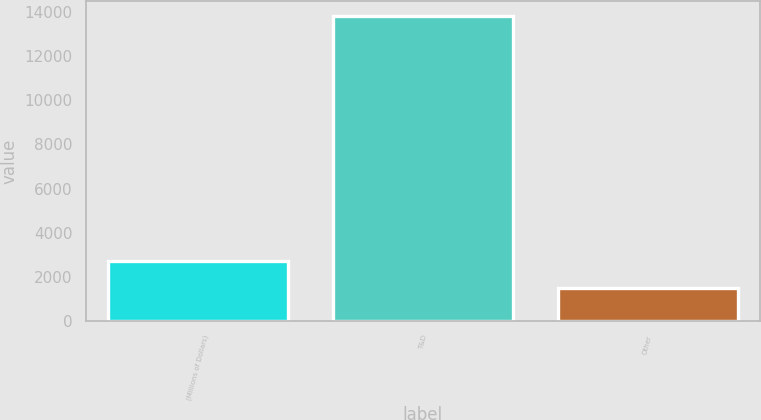<chart> <loc_0><loc_0><loc_500><loc_500><bar_chart><fcel>(Millions of Dollars)<fcel>T&D<fcel>Other<nl><fcel>2720.1<fcel>13818<fcel>1487<nl></chart> 